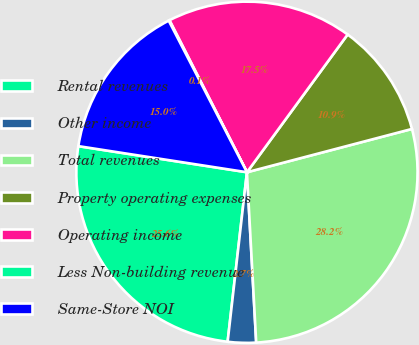Convert chart. <chart><loc_0><loc_0><loc_500><loc_500><pie_chart><fcel>Rental revenues<fcel>Other income<fcel>Total revenues<fcel>Property operating expenses<fcel>Operating income<fcel>Less Non-building revenue<fcel>Same-Store NOI<nl><fcel>25.64%<fcel>2.67%<fcel>28.22%<fcel>10.87%<fcel>17.55%<fcel>0.08%<fcel>14.97%<nl></chart> 